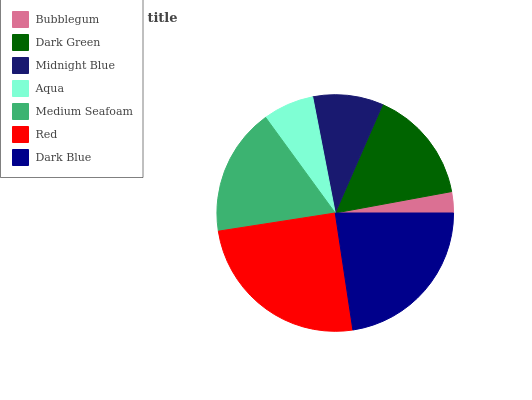Is Bubblegum the minimum?
Answer yes or no. Yes. Is Red the maximum?
Answer yes or no. Yes. Is Dark Green the minimum?
Answer yes or no. No. Is Dark Green the maximum?
Answer yes or no. No. Is Dark Green greater than Bubblegum?
Answer yes or no. Yes. Is Bubblegum less than Dark Green?
Answer yes or no. Yes. Is Bubblegum greater than Dark Green?
Answer yes or no. No. Is Dark Green less than Bubblegum?
Answer yes or no. No. Is Dark Green the high median?
Answer yes or no. Yes. Is Dark Green the low median?
Answer yes or no. Yes. Is Bubblegum the high median?
Answer yes or no. No. Is Midnight Blue the low median?
Answer yes or no. No. 